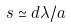<formula> <loc_0><loc_0><loc_500><loc_500>s \simeq d \lambda / a</formula> 